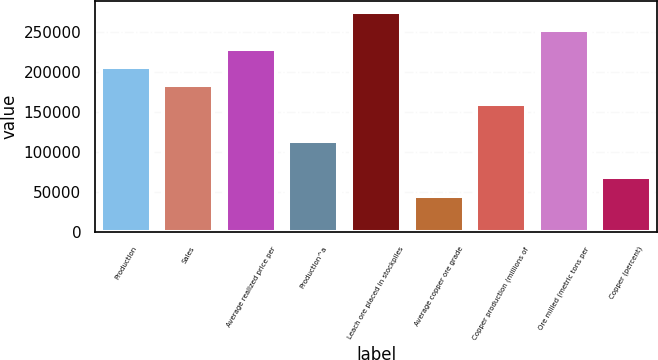Convert chart. <chart><loc_0><loc_0><loc_500><loc_500><bar_chart><fcel>Production<fcel>Sales<fcel>Average realized price per<fcel>Production^a<fcel>Leach ore placed in stockpiles<fcel>Average copper ore grade<fcel>Copper production (millions of<fcel>Ore milled (metric tons per<fcel>Copper (percent)<nl><fcel>206370<fcel>183440<fcel>229300<fcel>114650<fcel>275160<fcel>45860<fcel>160510<fcel>252230<fcel>68790<nl></chart> 